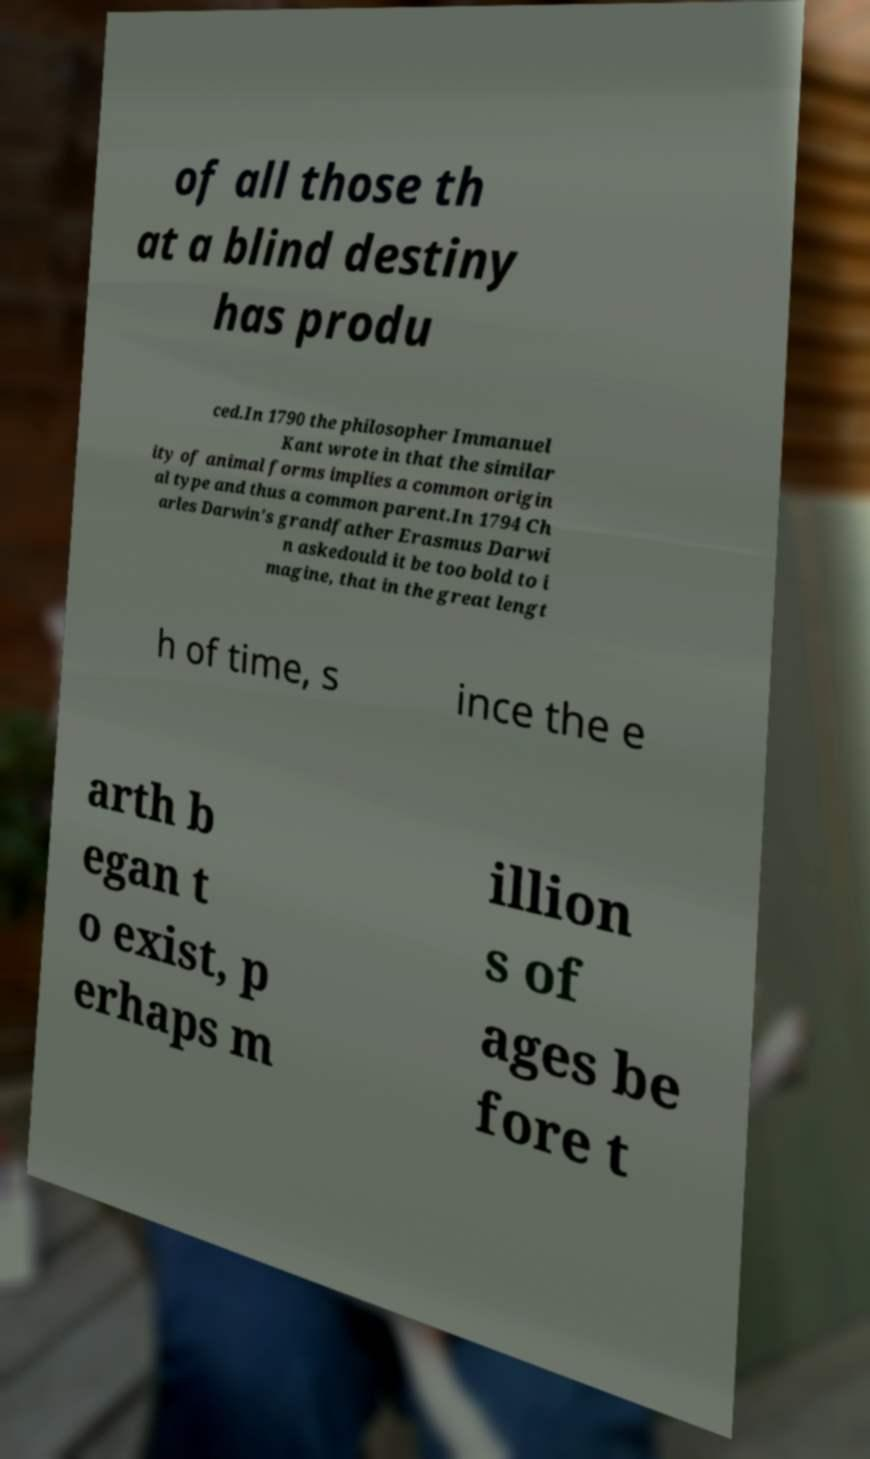There's text embedded in this image that I need extracted. Can you transcribe it verbatim? of all those th at a blind destiny has produ ced.In 1790 the philosopher Immanuel Kant wrote in that the similar ity of animal forms implies a common origin al type and thus a common parent.In 1794 Ch arles Darwin's grandfather Erasmus Darwi n askedould it be too bold to i magine, that in the great lengt h of time, s ince the e arth b egan t o exist, p erhaps m illion s of ages be fore t 